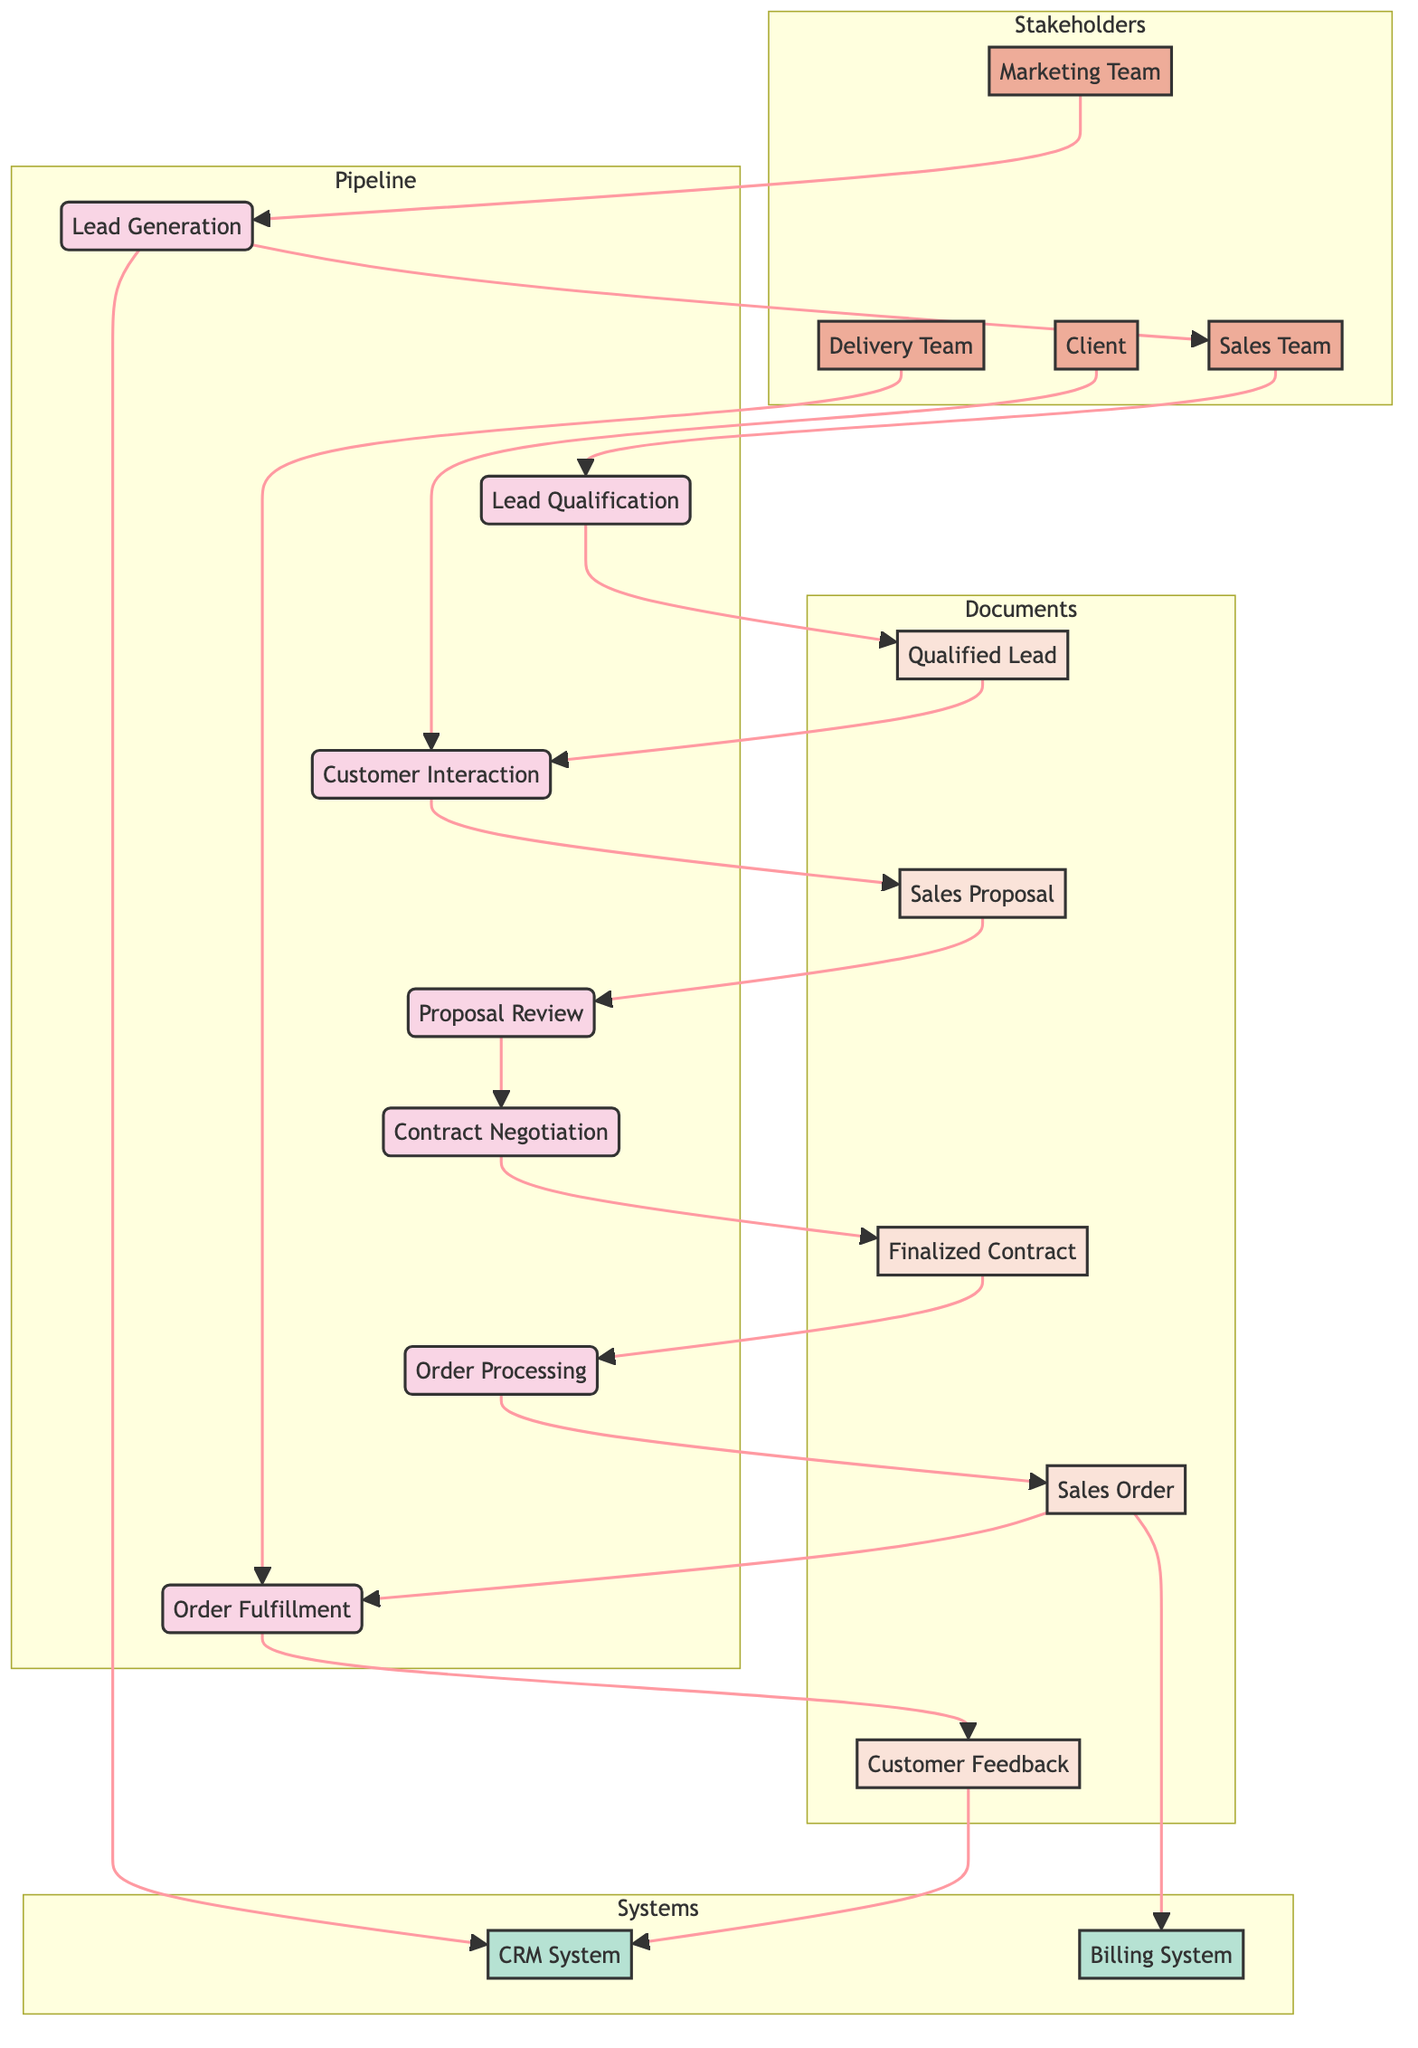What is the starting process of the pipeline? The starting process is indicated as "Lead Generation", which is the first process node in the diagram.
Answer: Lead Generation How many entities are involved in the sales pipeline management? By checking the diagram, the entities labeled are Sales Team, Marketing Team, Client, and Delivery Team. There are four entities in total.
Answer: 4 Which two processes come immediately after qualifying a lead? After the "Lead Qualification" process, the next two processes are "Customer Interaction" and "Proposal Review". They are the immediate successors in the diagram.
Answer: Customer Interaction, Proposal Review What data is generated after the "Contract Negotiation" process? After the "Contract Negotiation" process, the output is represented as "Finalized Contract", which is the data produced from the process.
Answer: Finalized Contract Which system is responsible for managing billing in the pipeline? The "Billing System" is the specific system designated to handle billing aspects of the sales pipeline according to the diagram.
Answer: Billing System What process does the Delivery Team interact with most directly? The "Delivery Team" interacts directly with the "Order Fulfillment" process, as this is the process they are assigned to within the diagram's structure.
Answer: Order Fulfillment What is the final data point collected in the diagram? The last data point in the data flow diagram is "Customer Feedback," which is the end output of the entire sales pipeline process.
Answer: Customer Feedback How many processes are depicted in the sales pipeline? The processes labeled in the diagram include Lead Generation, Lead Qualification, Customer Interaction, Proposal Review, Contract Negotiation, Order Processing, and Order Fulfillment. This totals to seven processes.
Answer: 7 What relationship do the Marketing Team and Sales Team have regarding lead generation? The "Marketing Team" contributes to the "Lead Generation" process as indicated by the directed arrow from Marketing Team to Lead Generation, showing their role in this part of the pipeline.
Answer: Contribution 